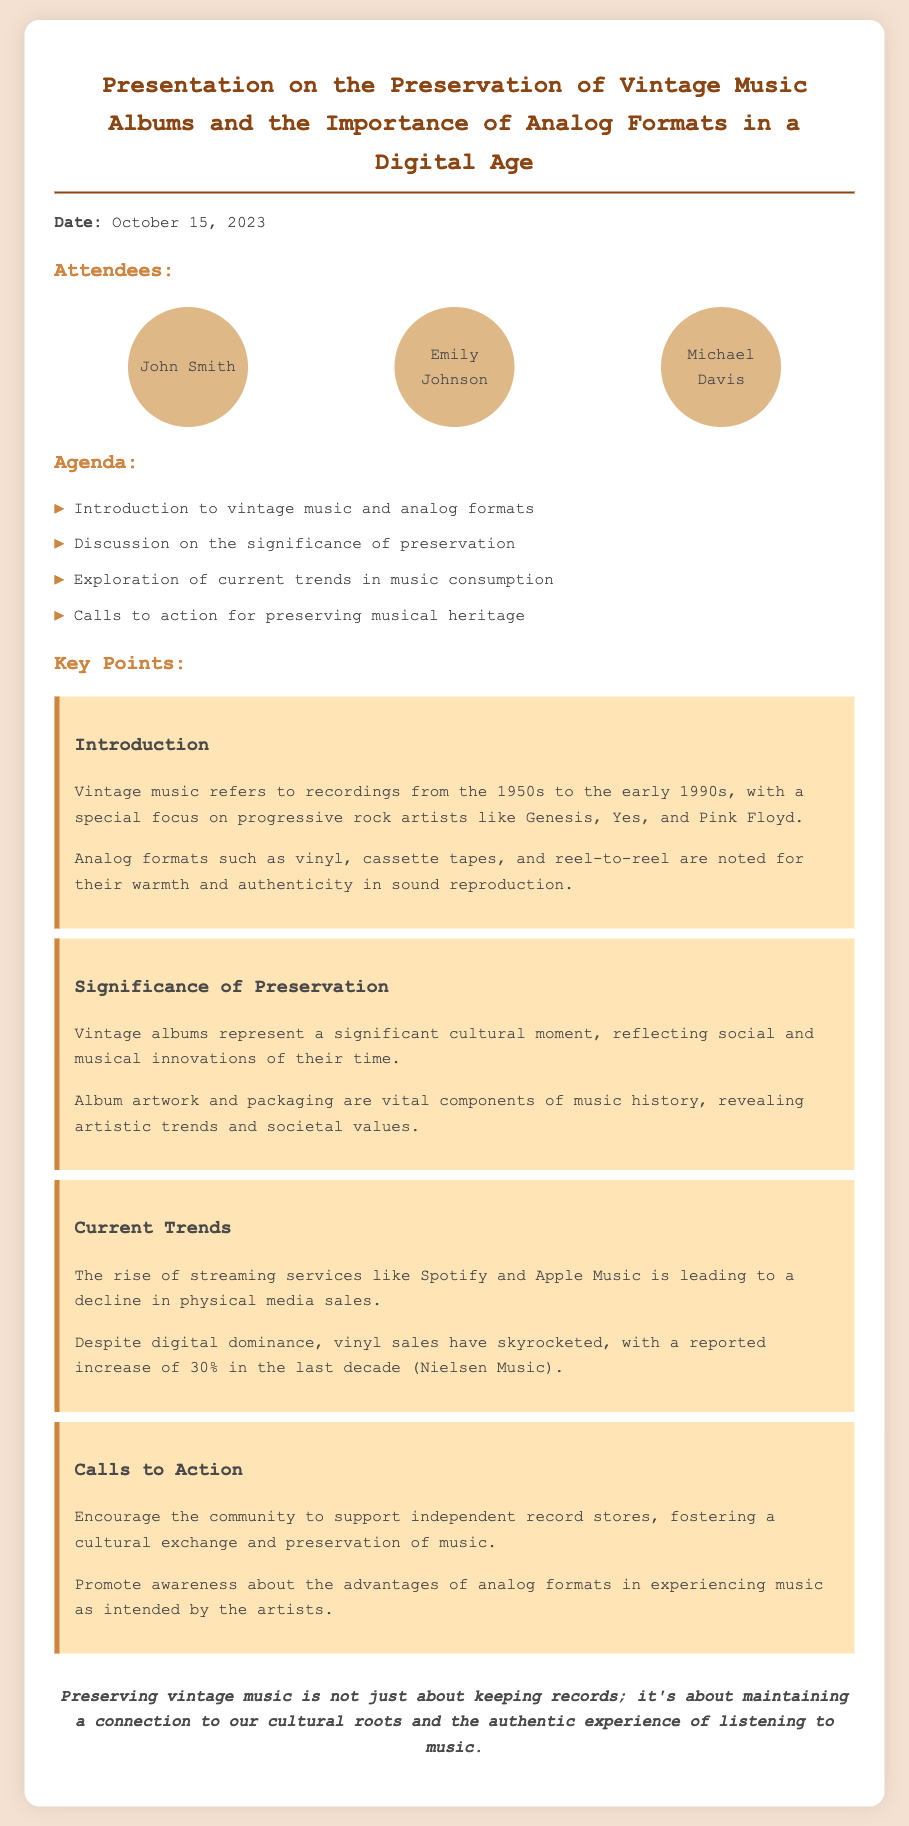what date was the meeting held? The document specifies that the meeting took place on October 15, 2023.
Answer: October 15, 2023 who are the attendees? The names of the attendees are listed in the document, including John Smith, Emily Johnson, and Michael Davis.
Answer: John Smith, Emily Johnson, Michael Davis what primary topic does the presentation focus on? The main topic of the presentation is the preservation of vintage music albums and the importance of analog formats.
Answer: Preservation of vintage music albums what does the rise of streaming services imply? The document discusses the impact of streaming services, indicating they lead to a decline in physical media sales.
Answer: Decline in physical media sales how much did vinyl sales increase in the last decade? The key point mentions a reported increase of 30% in vinyl sales in the last decade, according to Nielsen Music.
Answer: 30% what is a call to action mentioned in the meeting? One of the calls to action encourages supporting independent record stores.
Answer: Support independent record stores what years are considered as vintage music for this presentation? The document defines vintage music as recordings from the 1950s to the early 1990s.
Answer: 1950s to the early 1990s which music genres were highlighted during the presentation? The introduction specifically mentions progressive rock artists like Genesis, Yes, and Pink Floyd.
Answer: Progressive rock artists 